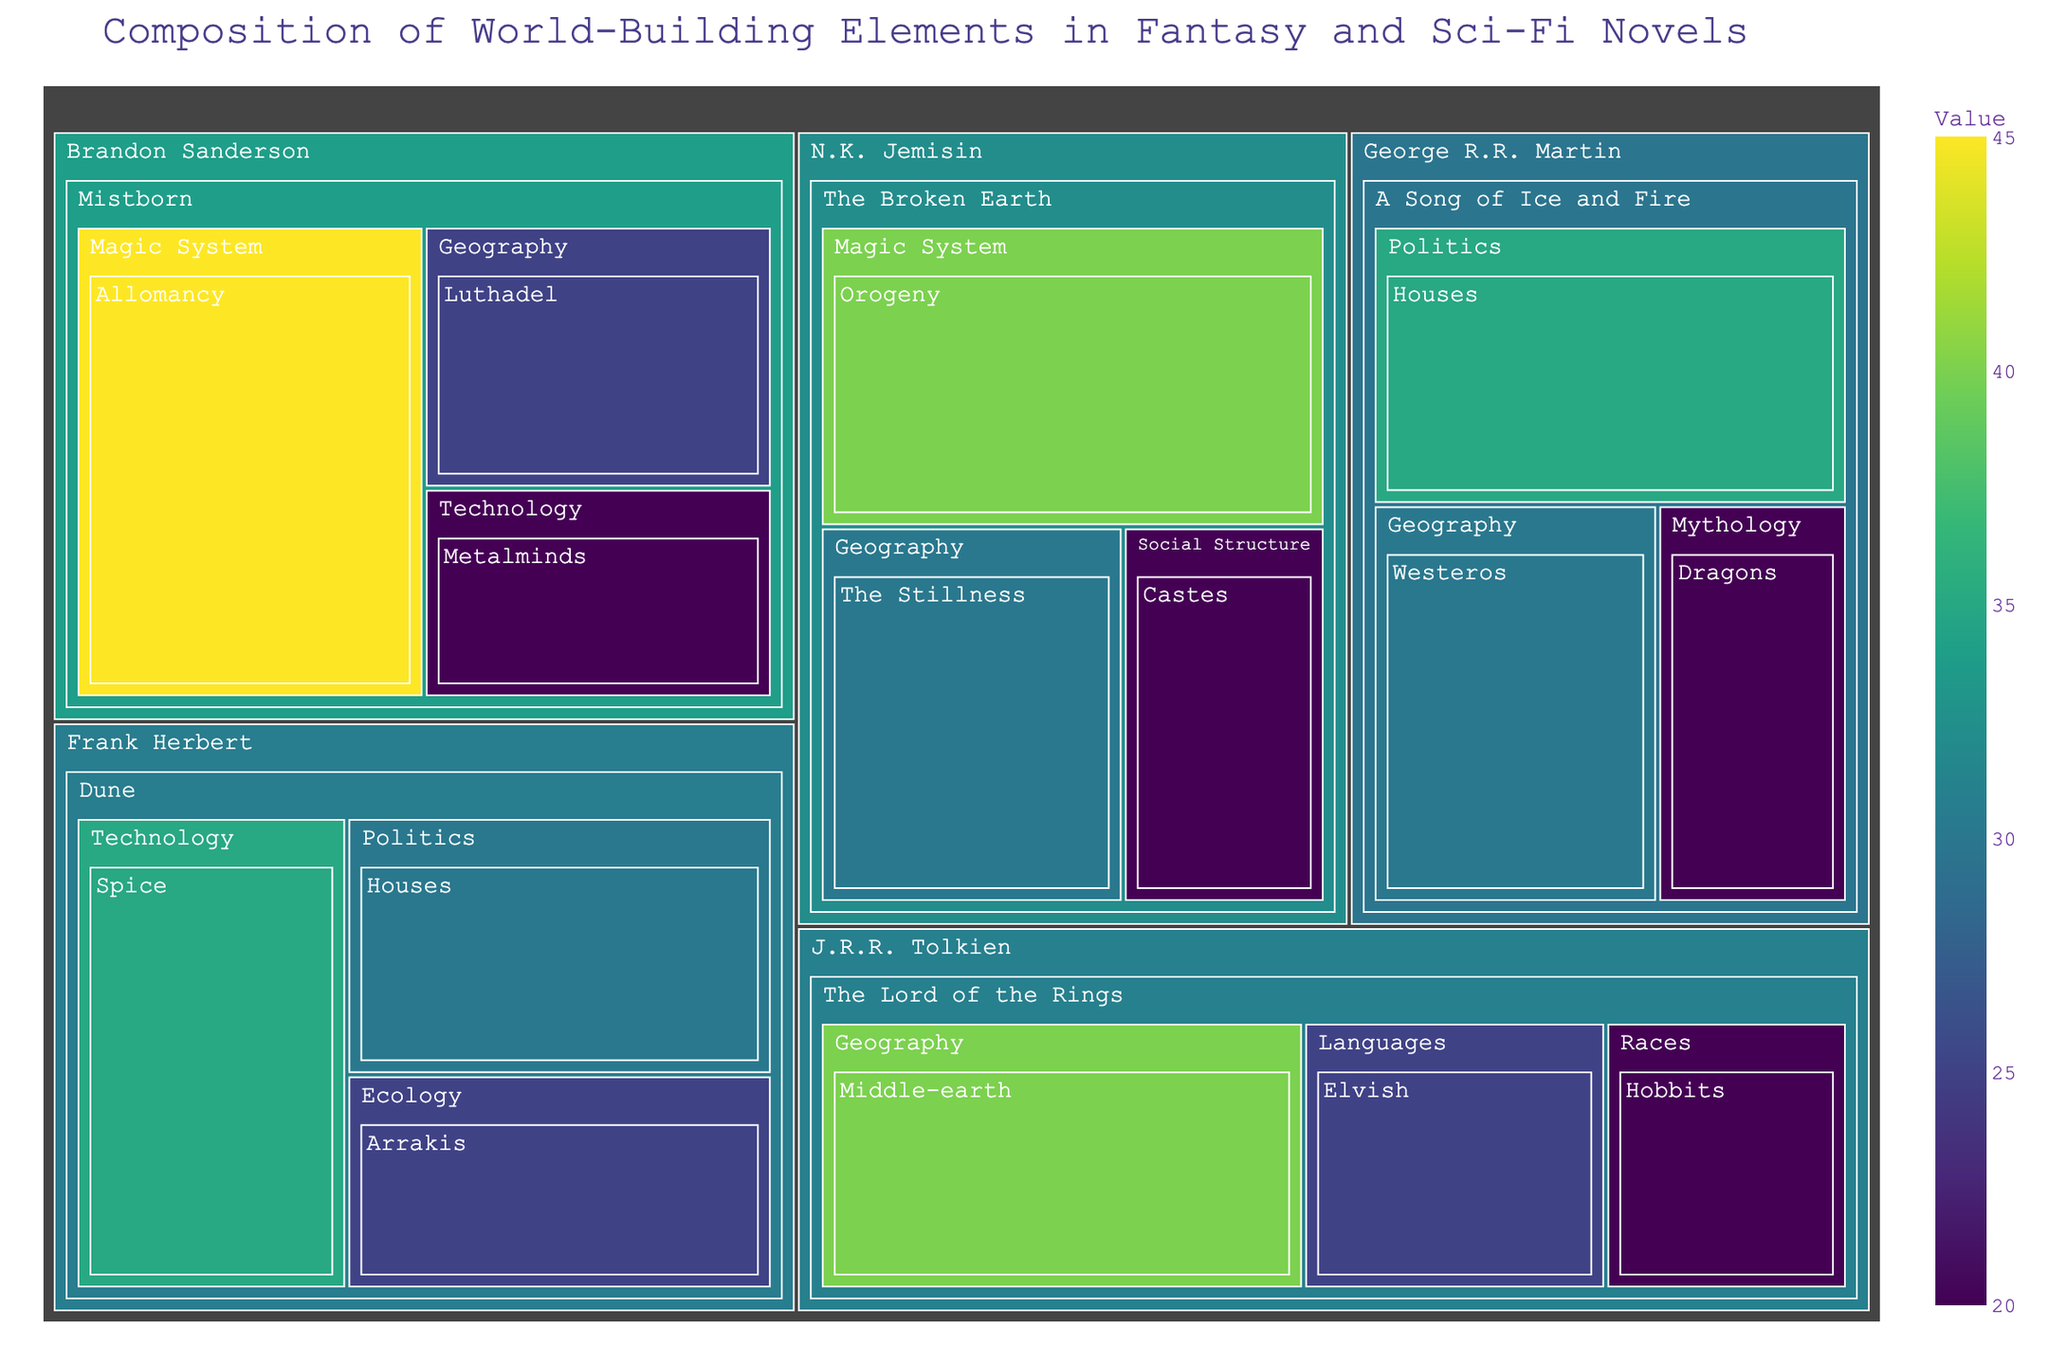what is the title of the figure? The title is usually located at the top of the figure and provides a summary of what the figure represents. In this case, the title would relate to the composition of world-building elements in specific genres.
Answer: Composition of World-Building Elements in Fantasy and Sci-Fi Novels Which author has the highest value allocated to a single element? Different colors and labels help to identify the elements and their values within the treemap. Look for the largest single section within each author's segments to determine which has the highest value.
Answer: Brandon Sanderson What is the sum of the values of all elements under George R.R. Martin? Identify and add the values of all elements listed under George R.R. Martin in the treemap, which include 35 (Houses), 30 (Westeros), and 20 (Dragons).
Answer: 85 Which series has the most diverse set of categories? Look at the number of different categories under each series in the treemap. Each category has a unique label, so count the distinct categories under each series.
Answer: Mistborn Compare the total values of the 'Magic System' category between N.K. Jemisin's and Brandon Sanderson's series. Which author allocates more value to this category? Identify and sum the values of the 'Magic System' category for both authors. N.K. Jemisin has 40 for Orogeny, while Brandon Sanderson has 45 for Allomancy.
Answer: Brandon Sanderson allocates more Which element in J.R.R. Tolkien's series has the second-highest value? Within the section for J.R.R. Tolkien, compare the values of the different elements listed: 40 (Middle-earth), 25 (Elvish), and 20 (Hobbits) to find the second-highest.
Answer: Elvish How does the composition of world-building elements in the Dune series differ from A Song of Ice and Fire? Compare the categories and their values in the sections allocated for Dune and A Song of Ice and Fire. Note the unique and overlapping categories and how their values differ.
Answer: Dune focuses more on Technology (Spice), while A Song of Ice and Fire emphasizes Politics (Houses) and Geography (Westeros) What is the value difference between the 'Geography' category in 'The Broken Earth' and 'The Lord of the Rings' series? Calculate the difference by subtracting the value of 'Geography' in 'The Lord of the Rings' (40) from the value in 'The Broken Earth' (30).
Answer: 10 Which element has the highest value across all series? Examine the values of all elements and identify the highest one. The figure shows that Brandon Sanderson's Allomancy in the Mistborn series has the highest value.
Answer: Allomancy How does the treemap visually represent authors with more series compared to those with only one series? Notice the number of segments and the depth of the hierarchy; authors with more series will have multiple primary sections connecting to different series, while authors with one series will have a simpler, more focused segment structure.
Answer: Authors with single series have simpler segments 